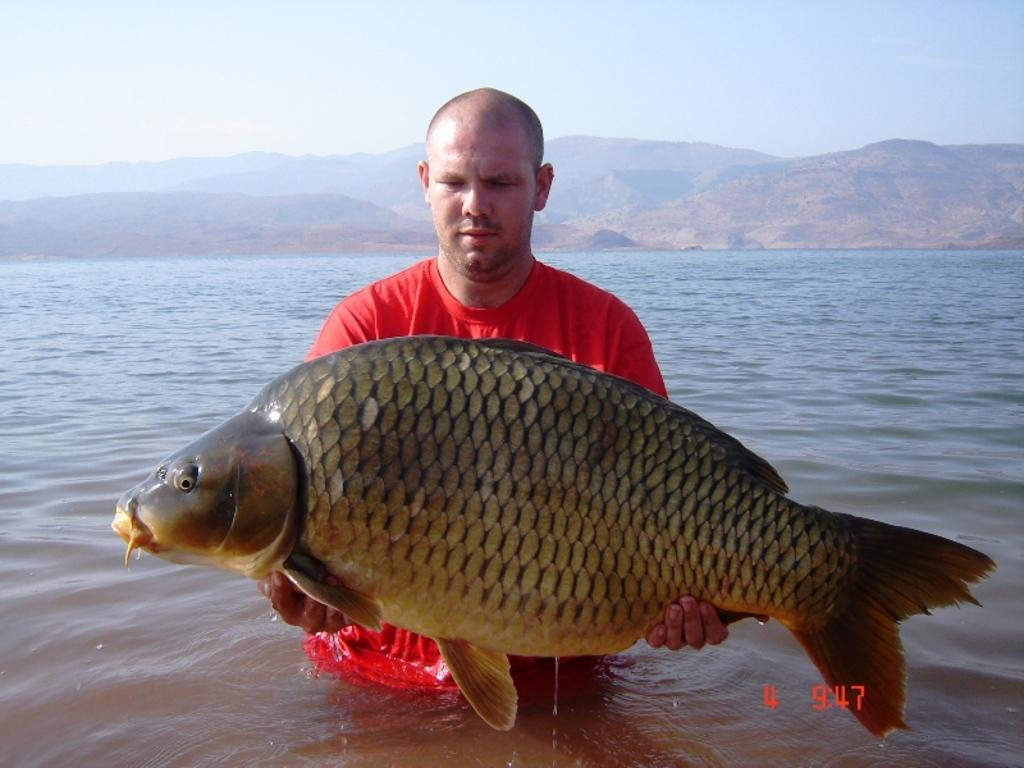Who is the main subject in the foreground of the image? There is a man in the foreground of the image. What is the man holding in his hand? The man is holding a fish in his hand. What can be seen in the background of the image? There is water, mountains, and the sky visible in the background of the image. Can you describe the setting where the image might have been taken? The image may have been taken near a lake, given the presence of water and mountains in the background. What type of ice is being used to keep the fish fresh in the image? There is no ice present in the image; the man is simply holding the fish in his hand. How many team members are visible in the image? There are no team members visible in the image. 